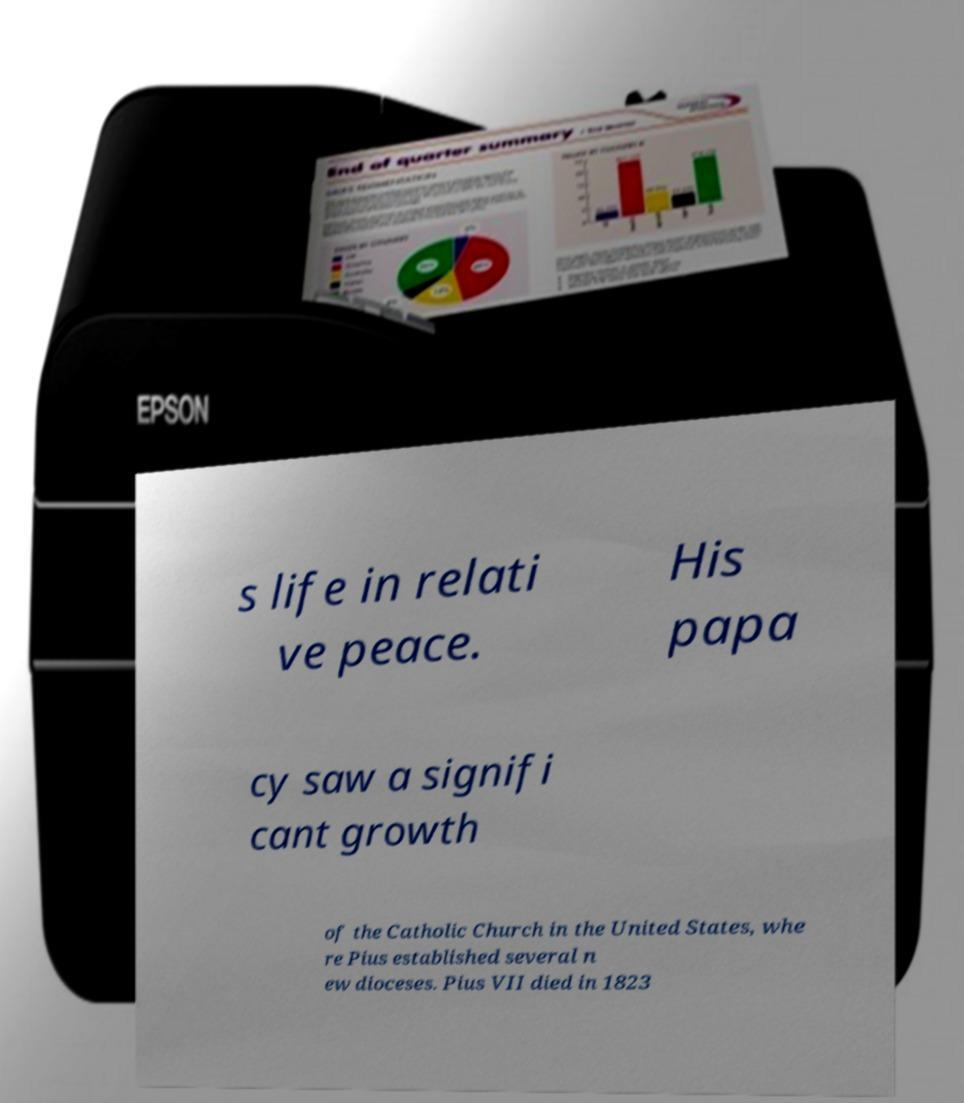There's text embedded in this image that I need extracted. Can you transcribe it verbatim? s life in relati ve peace. His papa cy saw a signifi cant growth of the Catholic Church in the United States, whe re Pius established several n ew dioceses. Pius VII died in 1823 